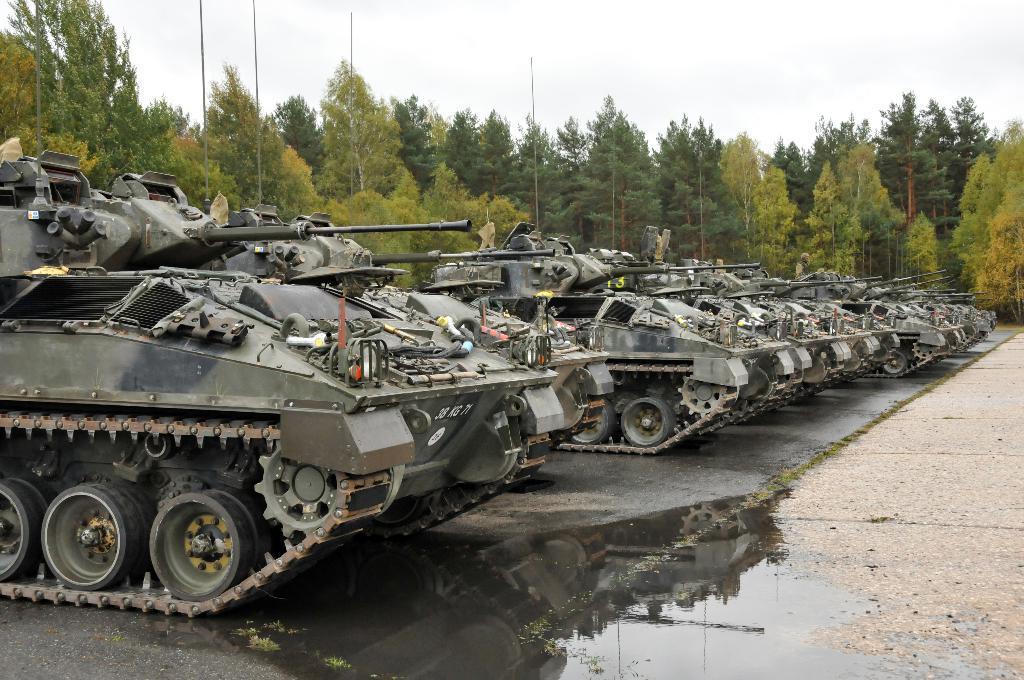Can you describe this image briefly? In this image we can see the tankers parked here, we can see the muddy water, trees and the sky in the background. 